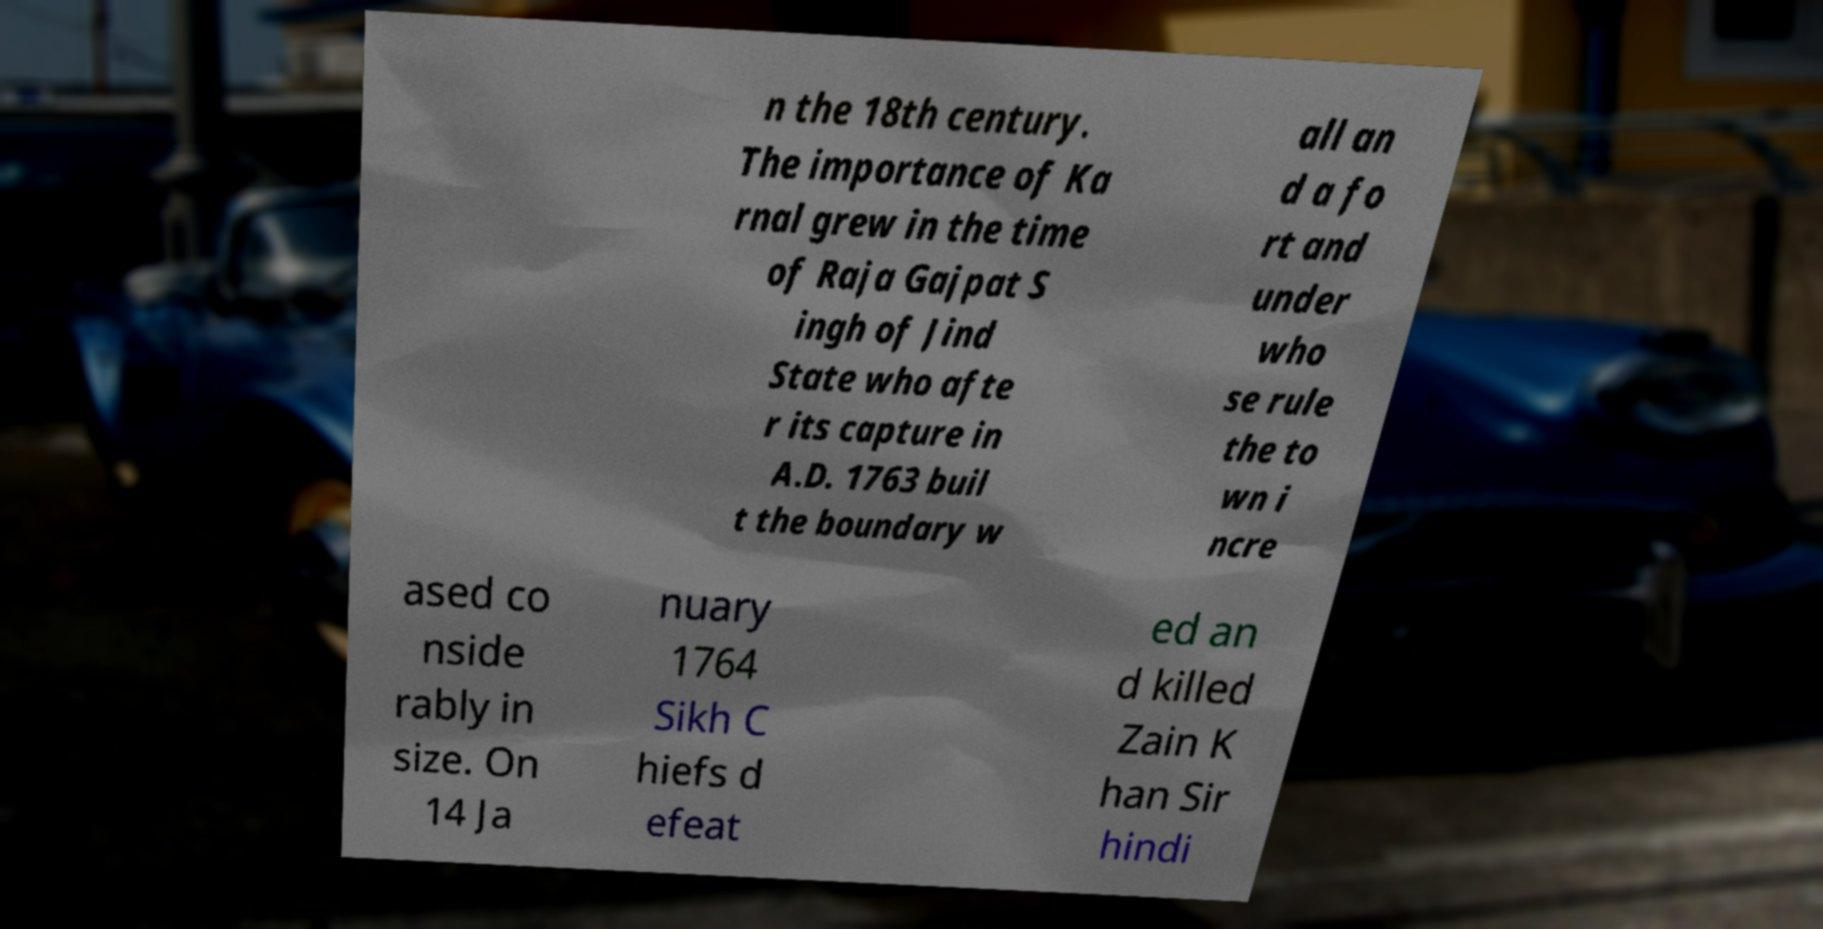Please read and relay the text visible in this image. What does it say? n the 18th century. The importance of Ka rnal grew in the time of Raja Gajpat S ingh of Jind State who afte r its capture in A.D. 1763 buil t the boundary w all an d a fo rt and under who se rule the to wn i ncre ased co nside rably in size. On 14 Ja nuary 1764 Sikh C hiefs d efeat ed an d killed Zain K han Sir hindi 